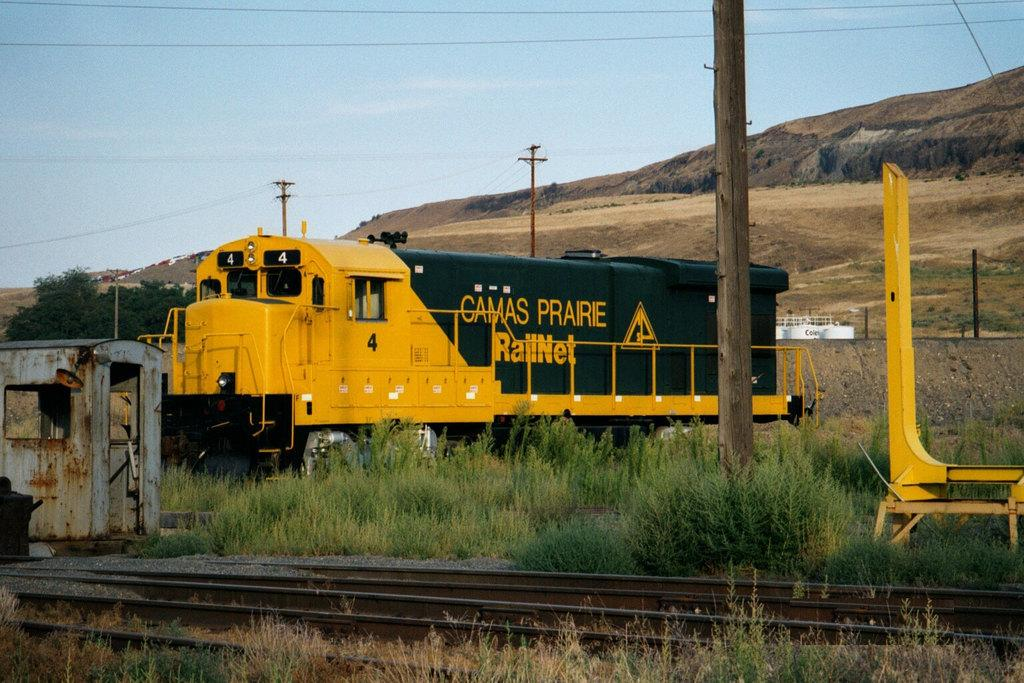What is the main subject of the image? The main subject of the image is a train engine. What is the train engine positioned on in the image? The train engine is positioned on railway tracks. What type of vegetation can be seen in the image? Plants, a tree, and grass are visible in the image. What man-made structures are present in the image? Electric poles and cables are visible in the image. What natural features can be seen in the image? Mountains are visible in the image. What color object is present in the image? There is a white color object in the image. What is visible in the background of the image? The sky is visible in the image. How many people are on the edge of the stone in the image? There is no stone or people on the edge present in the image. 